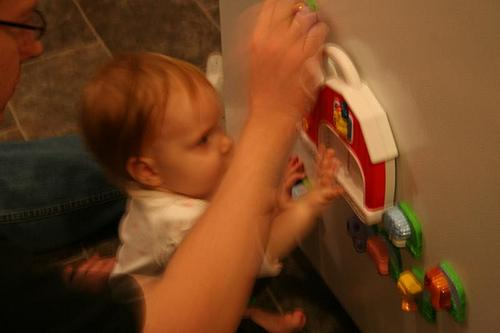What are the two using to play?

Choices:
A) screen
B) poster
C) dresser
D) refrigerator refrigerator 